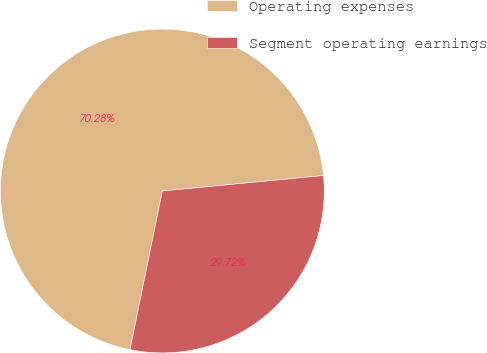Convert chart to OTSL. <chart><loc_0><loc_0><loc_500><loc_500><pie_chart><fcel>Operating expenses<fcel>Segment operating earnings<nl><fcel>70.28%<fcel>29.72%<nl></chart> 